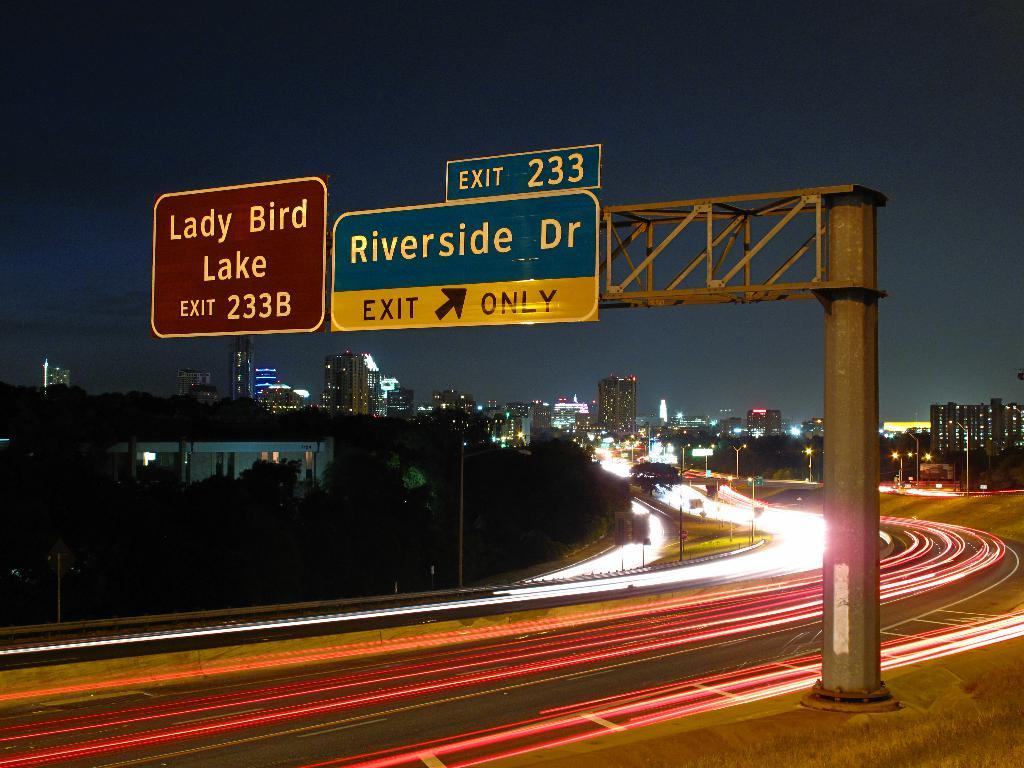<image>
Provide a brief description of the given image. a riverside dr sign that is above the highway 